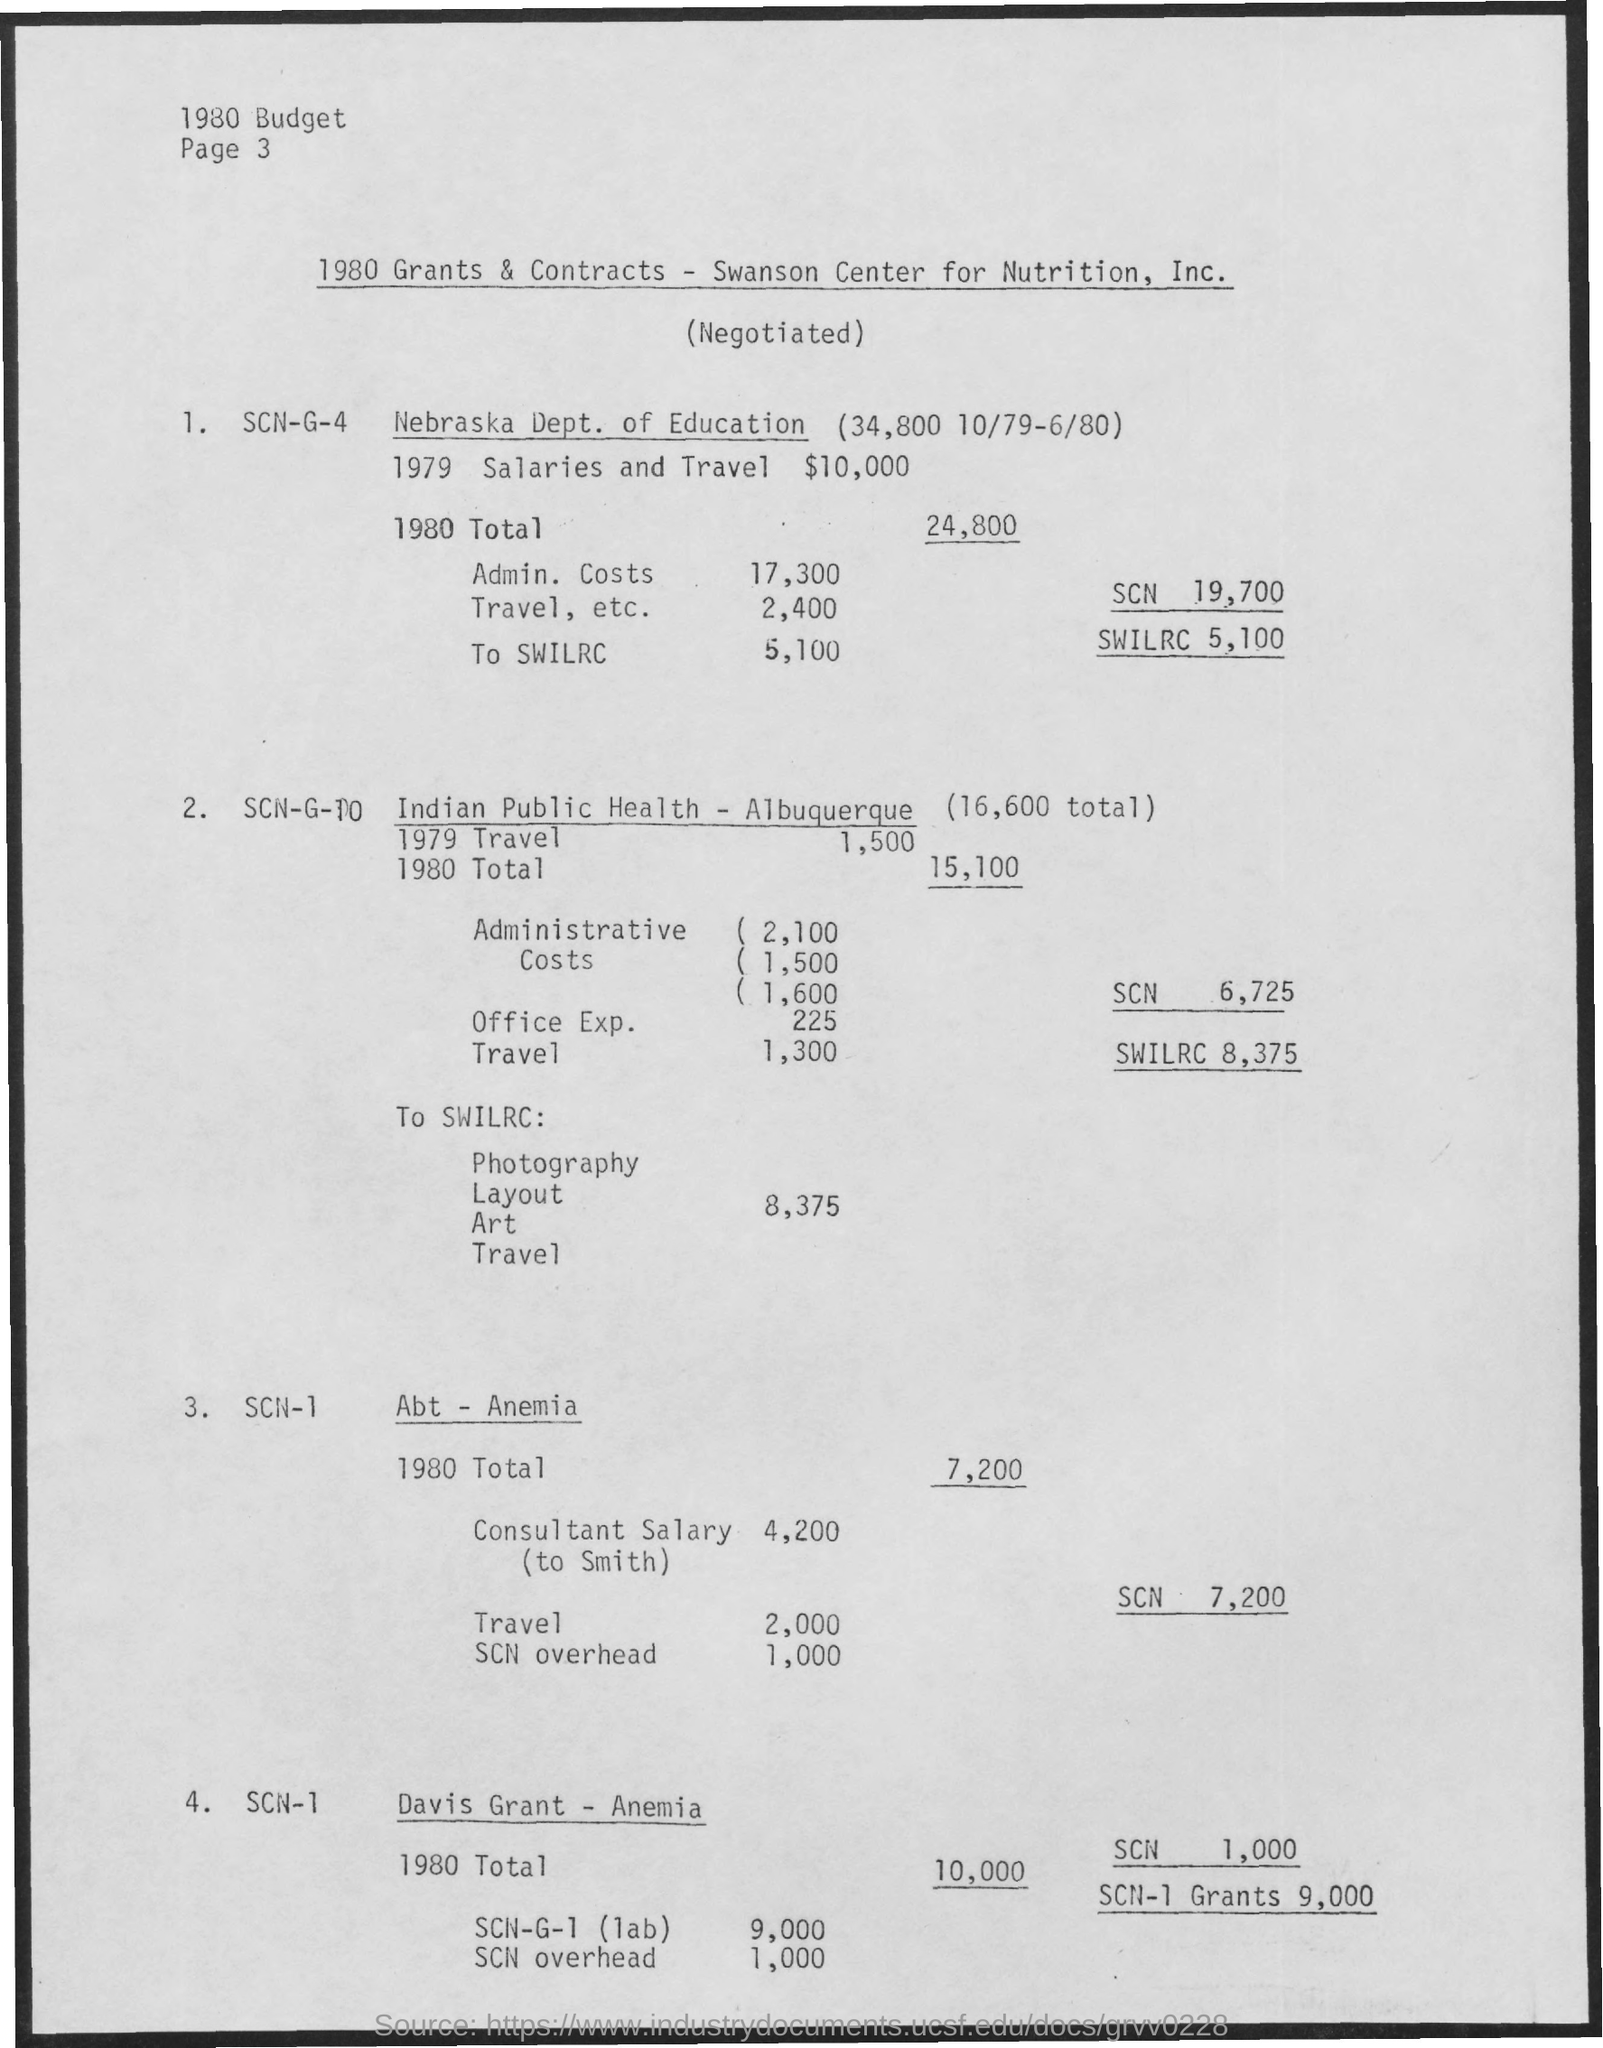Can you specify what expenses are covered under the 'Travel, etc.' category in the Nebraska Dept. of Education budget for 1980? The 'Travel, etc.' category for the Nebraska Dept. of Education in 1980 likely includes expenses related to transportation, lodging, and other travel-related costs necessary for the functioning of the department. However, without more detailed breakdowns, we cannot specify exact items or events covered by the $2,400 budgetary allotment. 